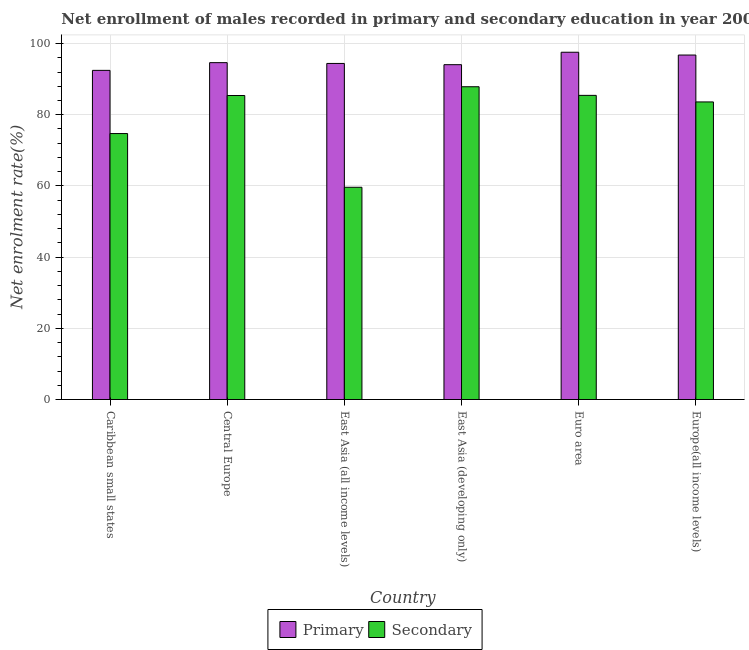How many different coloured bars are there?
Your response must be concise. 2. How many groups of bars are there?
Keep it short and to the point. 6. Are the number of bars per tick equal to the number of legend labels?
Your answer should be compact. Yes. Are the number of bars on each tick of the X-axis equal?
Keep it short and to the point. Yes. How many bars are there on the 2nd tick from the right?
Give a very brief answer. 2. What is the label of the 2nd group of bars from the left?
Your answer should be compact. Central Europe. In how many cases, is the number of bars for a given country not equal to the number of legend labels?
Provide a succinct answer. 0. What is the enrollment rate in secondary education in Euro area?
Your answer should be compact. 85.44. Across all countries, what is the maximum enrollment rate in primary education?
Your answer should be compact. 97.55. Across all countries, what is the minimum enrollment rate in secondary education?
Provide a short and direct response. 59.62. In which country was the enrollment rate in primary education maximum?
Provide a succinct answer. Euro area. In which country was the enrollment rate in secondary education minimum?
Offer a terse response. East Asia (all income levels). What is the total enrollment rate in primary education in the graph?
Offer a very short reply. 569.87. What is the difference between the enrollment rate in secondary education in Caribbean small states and that in Europe(all income levels)?
Your answer should be compact. -8.88. What is the difference between the enrollment rate in primary education in Euro area and the enrollment rate in secondary education in Central Europe?
Your answer should be very brief. 12.15. What is the average enrollment rate in secondary education per country?
Keep it short and to the point. 79.44. What is the difference between the enrollment rate in primary education and enrollment rate in secondary education in Euro area?
Ensure brevity in your answer.  12.12. In how many countries, is the enrollment rate in primary education greater than 24 %?
Offer a very short reply. 6. What is the ratio of the enrollment rate in secondary education in Central Europe to that in Europe(all income levels)?
Your answer should be very brief. 1.02. What is the difference between the highest and the second highest enrollment rate in secondary education?
Make the answer very short. 2.42. What is the difference between the highest and the lowest enrollment rate in primary education?
Ensure brevity in your answer.  5.09. What does the 1st bar from the left in Central Europe represents?
Your answer should be compact. Primary. What does the 2nd bar from the right in Euro area represents?
Your answer should be compact. Primary. Are all the bars in the graph horizontal?
Keep it short and to the point. No. How many countries are there in the graph?
Provide a short and direct response. 6. Does the graph contain grids?
Give a very brief answer. Yes. Where does the legend appear in the graph?
Your answer should be very brief. Bottom center. What is the title of the graph?
Give a very brief answer. Net enrollment of males recorded in primary and secondary education in year 2004. Does "GDP at market prices" appear as one of the legend labels in the graph?
Make the answer very short. No. What is the label or title of the X-axis?
Your answer should be compact. Country. What is the label or title of the Y-axis?
Provide a succinct answer. Net enrolment rate(%). What is the Net enrolment rate(%) of Primary in Caribbean small states?
Offer a terse response. 92.46. What is the Net enrolment rate(%) of Secondary in Caribbean small states?
Give a very brief answer. 74.71. What is the Net enrolment rate(%) in Primary in Central Europe?
Make the answer very short. 94.63. What is the Net enrolment rate(%) in Secondary in Central Europe?
Your answer should be compact. 85.4. What is the Net enrolment rate(%) of Primary in East Asia (all income levels)?
Give a very brief answer. 94.41. What is the Net enrolment rate(%) of Secondary in East Asia (all income levels)?
Keep it short and to the point. 59.62. What is the Net enrolment rate(%) in Primary in East Asia (developing only)?
Provide a short and direct response. 94.06. What is the Net enrolment rate(%) in Secondary in East Asia (developing only)?
Make the answer very short. 87.86. What is the Net enrolment rate(%) in Primary in Euro area?
Offer a very short reply. 97.55. What is the Net enrolment rate(%) in Secondary in Euro area?
Offer a terse response. 85.44. What is the Net enrolment rate(%) in Primary in Europe(all income levels)?
Offer a very short reply. 96.76. What is the Net enrolment rate(%) in Secondary in Europe(all income levels)?
Make the answer very short. 83.59. Across all countries, what is the maximum Net enrolment rate(%) in Primary?
Your answer should be compact. 97.55. Across all countries, what is the maximum Net enrolment rate(%) in Secondary?
Make the answer very short. 87.86. Across all countries, what is the minimum Net enrolment rate(%) in Primary?
Your response must be concise. 92.46. Across all countries, what is the minimum Net enrolment rate(%) in Secondary?
Keep it short and to the point. 59.62. What is the total Net enrolment rate(%) of Primary in the graph?
Ensure brevity in your answer.  569.87. What is the total Net enrolment rate(%) of Secondary in the graph?
Provide a short and direct response. 476.62. What is the difference between the Net enrolment rate(%) in Primary in Caribbean small states and that in Central Europe?
Give a very brief answer. -2.17. What is the difference between the Net enrolment rate(%) in Secondary in Caribbean small states and that in Central Europe?
Ensure brevity in your answer.  -10.69. What is the difference between the Net enrolment rate(%) in Primary in Caribbean small states and that in East Asia (all income levels)?
Ensure brevity in your answer.  -1.94. What is the difference between the Net enrolment rate(%) in Secondary in Caribbean small states and that in East Asia (all income levels)?
Your response must be concise. 15.09. What is the difference between the Net enrolment rate(%) of Primary in Caribbean small states and that in East Asia (developing only)?
Your answer should be compact. -1.6. What is the difference between the Net enrolment rate(%) in Secondary in Caribbean small states and that in East Asia (developing only)?
Your response must be concise. -13.15. What is the difference between the Net enrolment rate(%) in Primary in Caribbean small states and that in Euro area?
Make the answer very short. -5.09. What is the difference between the Net enrolment rate(%) of Secondary in Caribbean small states and that in Euro area?
Your answer should be very brief. -10.72. What is the difference between the Net enrolment rate(%) in Primary in Caribbean small states and that in Europe(all income levels)?
Provide a succinct answer. -4.3. What is the difference between the Net enrolment rate(%) of Secondary in Caribbean small states and that in Europe(all income levels)?
Provide a succinct answer. -8.88. What is the difference between the Net enrolment rate(%) of Primary in Central Europe and that in East Asia (all income levels)?
Keep it short and to the point. 0.22. What is the difference between the Net enrolment rate(%) in Secondary in Central Europe and that in East Asia (all income levels)?
Your response must be concise. 25.78. What is the difference between the Net enrolment rate(%) of Primary in Central Europe and that in East Asia (developing only)?
Offer a terse response. 0.57. What is the difference between the Net enrolment rate(%) in Secondary in Central Europe and that in East Asia (developing only)?
Offer a very short reply. -2.46. What is the difference between the Net enrolment rate(%) in Primary in Central Europe and that in Euro area?
Your answer should be compact. -2.92. What is the difference between the Net enrolment rate(%) of Secondary in Central Europe and that in Euro area?
Offer a terse response. -0.04. What is the difference between the Net enrolment rate(%) of Primary in Central Europe and that in Europe(all income levels)?
Give a very brief answer. -2.14. What is the difference between the Net enrolment rate(%) in Secondary in Central Europe and that in Europe(all income levels)?
Give a very brief answer. 1.8. What is the difference between the Net enrolment rate(%) in Primary in East Asia (all income levels) and that in East Asia (developing only)?
Offer a very short reply. 0.35. What is the difference between the Net enrolment rate(%) in Secondary in East Asia (all income levels) and that in East Asia (developing only)?
Make the answer very short. -28.24. What is the difference between the Net enrolment rate(%) in Primary in East Asia (all income levels) and that in Euro area?
Make the answer very short. -3.15. What is the difference between the Net enrolment rate(%) of Secondary in East Asia (all income levels) and that in Euro area?
Keep it short and to the point. -25.82. What is the difference between the Net enrolment rate(%) in Primary in East Asia (all income levels) and that in Europe(all income levels)?
Offer a very short reply. -2.36. What is the difference between the Net enrolment rate(%) of Secondary in East Asia (all income levels) and that in Europe(all income levels)?
Give a very brief answer. -23.97. What is the difference between the Net enrolment rate(%) of Primary in East Asia (developing only) and that in Euro area?
Offer a very short reply. -3.49. What is the difference between the Net enrolment rate(%) in Secondary in East Asia (developing only) and that in Euro area?
Offer a terse response. 2.42. What is the difference between the Net enrolment rate(%) of Primary in East Asia (developing only) and that in Europe(all income levels)?
Offer a terse response. -2.71. What is the difference between the Net enrolment rate(%) of Secondary in East Asia (developing only) and that in Europe(all income levels)?
Provide a succinct answer. 4.27. What is the difference between the Net enrolment rate(%) in Primary in Euro area and that in Europe(all income levels)?
Your response must be concise. 0.79. What is the difference between the Net enrolment rate(%) in Secondary in Euro area and that in Europe(all income levels)?
Make the answer very short. 1.84. What is the difference between the Net enrolment rate(%) in Primary in Caribbean small states and the Net enrolment rate(%) in Secondary in Central Europe?
Offer a terse response. 7.06. What is the difference between the Net enrolment rate(%) in Primary in Caribbean small states and the Net enrolment rate(%) in Secondary in East Asia (all income levels)?
Make the answer very short. 32.84. What is the difference between the Net enrolment rate(%) in Primary in Caribbean small states and the Net enrolment rate(%) in Secondary in East Asia (developing only)?
Ensure brevity in your answer.  4.6. What is the difference between the Net enrolment rate(%) of Primary in Caribbean small states and the Net enrolment rate(%) of Secondary in Euro area?
Your answer should be compact. 7.02. What is the difference between the Net enrolment rate(%) in Primary in Caribbean small states and the Net enrolment rate(%) in Secondary in Europe(all income levels)?
Your answer should be very brief. 8.87. What is the difference between the Net enrolment rate(%) in Primary in Central Europe and the Net enrolment rate(%) in Secondary in East Asia (all income levels)?
Provide a succinct answer. 35.01. What is the difference between the Net enrolment rate(%) of Primary in Central Europe and the Net enrolment rate(%) of Secondary in East Asia (developing only)?
Your response must be concise. 6.77. What is the difference between the Net enrolment rate(%) in Primary in Central Europe and the Net enrolment rate(%) in Secondary in Euro area?
Keep it short and to the point. 9.19. What is the difference between the Net enrolment rate(%) of Primary in Central Europe and the Net enrolment rate(%) of Secondary in Europe(all income levels)?
Offer a terse response. 11.04. What is the difference between the Net enrolment rate(%) of Primary in East Asia (all income levels) and the Net enrolment rate(%) of Secondary in East Asia (developing only)?
Ensure brevity in your answer.  6.55. What is the difference between the Net enrolment rate(%) of Primary in East Asia (all income levels) and the Net enrolment rate(%) of Secondary in Euro area?
Keep it short and to the point. 8.97. What is the difference between the Net enrolment rate(%) of Primary in East Asia (all income levels) and the Net enrolment rate(%) of Secondary in Europe(all income levels)?
Offer a terse response. 10.81. What is the difference between the Net enrolment rate(%) in Primary in East Asia (developing only) and the Net enrolment rate(%) in Secondary in Euro area?
Provide a short and direct response. 8.62. What is the difference between the Net enrolment rate(%) in Primary in East Asia (developing only) and the Net enrolment rate(%) in Secondary in Europe(all income levels)?
Make the answer very short. 10.47. What is the difference between the Net enrolment rate(%) of Primary in Euro area and the Net enrolment rate(%) of Secondary in Europe(all income levels)?
Provide a succinct answer. 13.96. What is the average Net enrolment rate(%) of Primary per country?
Give a very brief answer. 94.98. What is the average Net enrolment rate(%) in Secondary per country?
Give a very brief answer. 79.44. What is the difference between the Net enrolment rate(%) in Primary and Net enrolment rate(%) in Secondary in Caribbean small states?
Offer a terse response. 17.75. What is the difference between the Net enrolment rate(%) in Primary and Net enrolment rate(%) in Secondary in Central Europe?
Your answer should be very brief. 9.23. What is the difference between the Net enrolment rate(%) in Primary and Net enrolment rate(%) in Secondary in East Asia (all income levels)?
Ensure brevity in your answer.  34.79. What is the difference between the Net enrolment rate(%) in Primary and Net enrolment rate(%) in Secondary in Euro area?
Make the answer very short. 12.12. What is the difference between the Net enrolment rate(%) of Primary and Net enrolment rate(%) of Secondary in Europe(all income levels)?
Provide a succinct answer. 13.17. What is the ratio of the Net enrolment rate(%) in Primary in Caribbean small states to that in Central Europe?
Your response must be concise. 0.98. What is the ratio of the Net enrolment rate(%) in Secondary in Caribbean small states to that in Central Europe?
Offer a very short reply. 0.87. What is the ratio of the Net enrolment rate(%) of Primary in Caribbean small states to that in East Asia (all income levels)?
Keep it short and to the point. 0.98. What is the ratio of the Net enrolment rate(%) of Secondary in Caribbean small states to that in East Asia (all income levels)?
Offer a terse response. 1.25. What is the ratio of the Net enrolment rate(%) in Secondary in Caribbean small states to that in East Asia (developing only)?
Offer a terse response. 0.85. What is the ratio of the Net enrolment rate(%) of Primary in Caribbean small states to that in Euro area?
Ensure brevity in your answer.  0.95. What is the ratio of the Net enrolment rate(%) in Secondary in Caribbean small states to that in Euro area?
Offer a terse response. 0.87. What is the ratio of the Net enrolment rate(%) in Primary in Caribbean small states to that in Europe(all income levels)?
Keep it short and to the point. 0.96. What is the ratio of the Net enrolment rate(%) in Secondary in Caribbean small states to that in Europe(all income levels)?
Make the answer very short. 0.89. What is the ratio of the Net enrolment rate(%) of Primary in Central Europe to that in East Asia (all income levels)?
Make the answer very short. 1. What is the ratio of the Net enrolment rate(%) of Secondary in Central Europe to that in East Asia (all income levels)?
Provide a succinct answer. 1.43. What is the ratio of the Net enrolment rate(%) of Primary in Central Europe to that in Europe(all income levels)?
Your response must be concise. 0.98. What is the ratio of the Net enrolment rate(%) in Secondary in Central Europe to that in Europe(all income levels)?
Give a very brief answer. 1.02. What is the ratio of the Net enrolment rate(%) in Primary in East Asia (all income levels) to that in East Asia (developing only)?
Your response must be concise. 1. What is the ratio of the Net enrolment rate(%) of Secondary in East Asia (all income levels) to that in East Asia (developing only)?
Keep it short and to the point. 0.68. What is the ratio of the Net enrolment rate(%) of Primary in East Asia (all income levels) to that in Euro area?
Your answer should be very brief. 0.97. What is the ratio of the Net enrolment rate(%) in Secondary in East Asia (all income levels) to that in Euro area?
Offer a very short reply. 0.7. What is the ratio of the Net enrolment rate(%) in Primary in East Asia (all income levels) to that in Europe(all income levels)?
Offer a very short reply. 0.98. What is the ratio of the Net enrolment rate(%) of Secondary in East Asia (all income levels) to that in Europe(all income levels)?
Make the answer very short. 0.71. What is the ratio of the Net enrolment rate(%) of Primary in East Asia (developing only) to that in Euro area?
Offer a terse response. 0.96. What is the ratio of the Net enrolment rate(%) in Secondary in East Asia (developing only) to that in Euro area?
Keep it short and to the point. 1.03. What is the ratio of the Net enrolment rate(%) of Primary in East Asia (developing only) to that in Europe(all income levels)?
Your answer should be compact. 0.97. What is the ratio of the Net enrolment rate(%) in Secondary in East Asia (developing only) to that in Europe(all income levels)?
Your response must be concise. 1.05. What is the ratio of the Net enrolment rate(%) of Primary in Euro area to that in Europe(all income levels)?
Make the answer very short. 1.01. What is the ratio of the Net enrolment rate(%) of Secondary in Euro area to that in Europe(all income levels)?
Offer a very short reply. 1.02. What is the difference between the highest and the second highest Net enrolment rate(%) in Primary?
Keep it short and to the point. 0.79. What is the difference between the highest and the second highest Net enrolment rate(%) of Secondary?
Provide a short and direct response. 2.42. What is the difference between the highest and the lowest Net enrolment rate(%) of Primary?
Offer a terse response. 5.09. What is the difference between the highest and the lowest Net enrolment rate(%) of Secondary?
Offer a terse response. 28.24. 